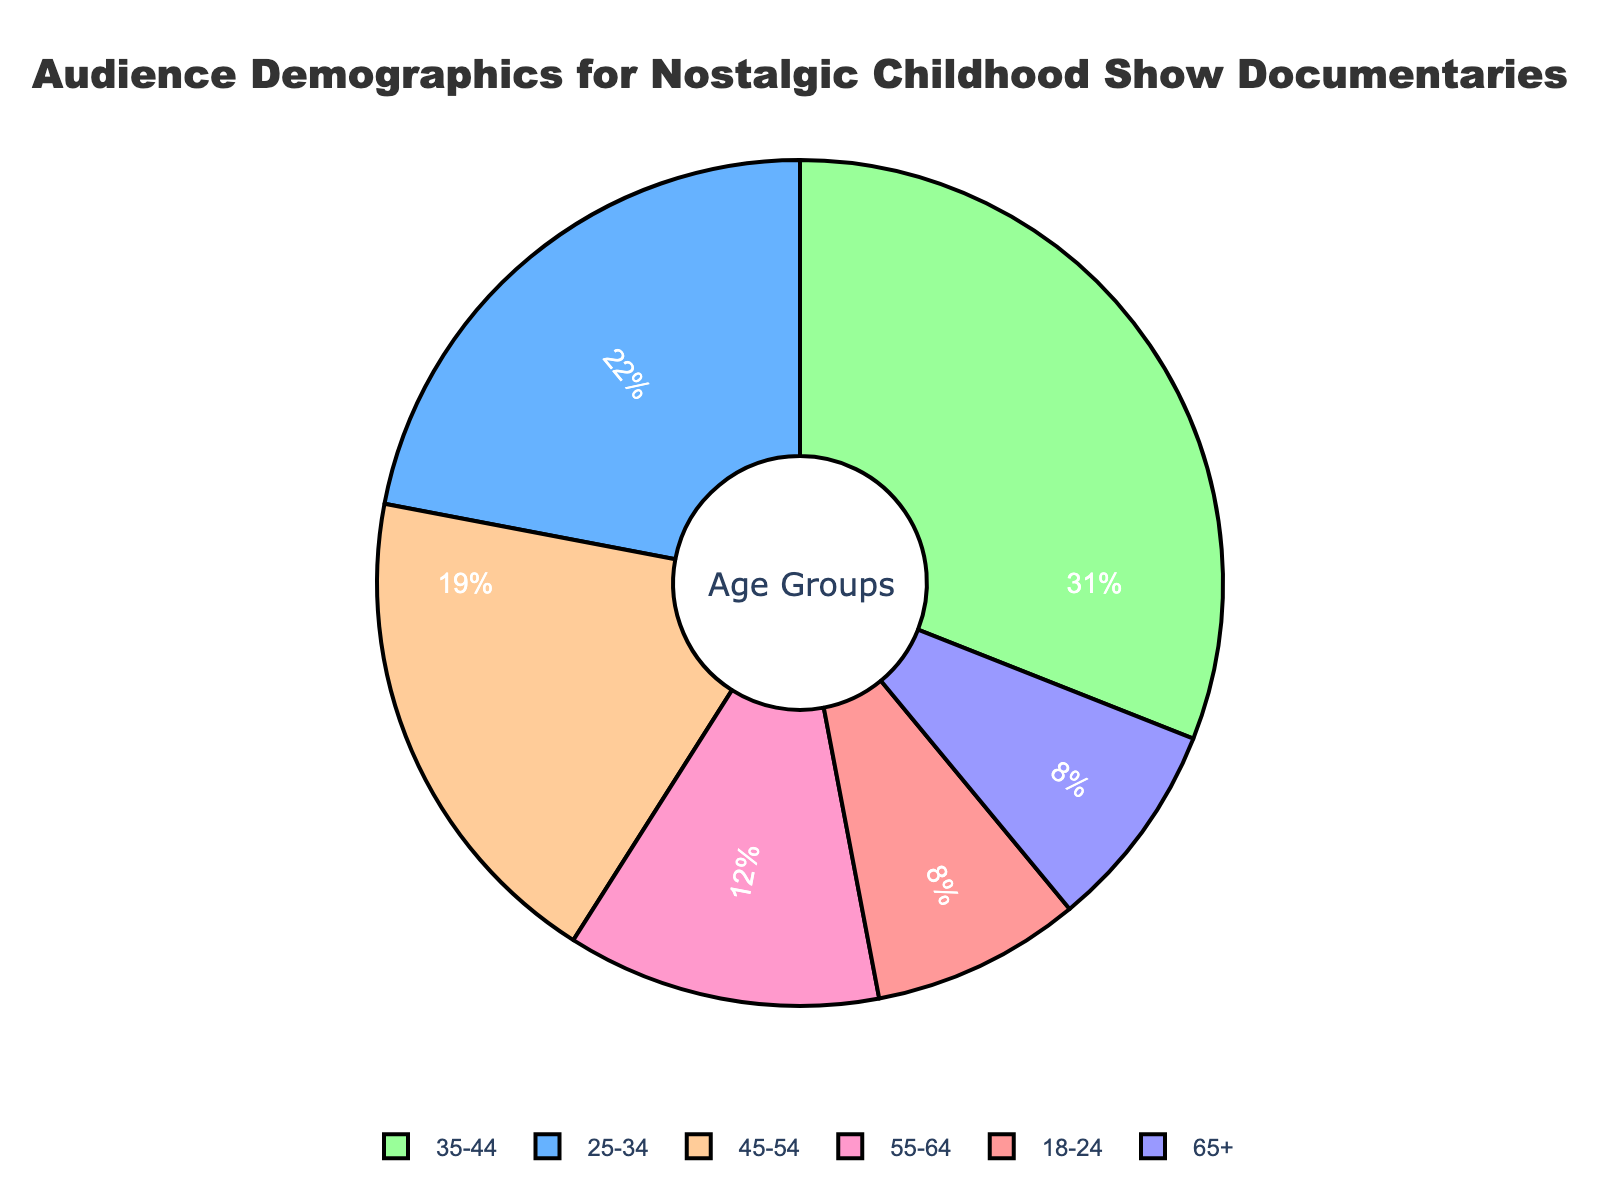What age group forms the largest portion of the audience? The pie chart shows different age groups and their respective percentages. The largest portion is associated with the age group that has the highest percentage. From the chart, the 35-44 age group has the largest portion with 31%.
Answer: 35-44 Which two age groups together make up over half of the audience? To determine which two age groups together make up over half (more than 50%), we look for the top two age groups by percentage and sum them. The two largest age groups are 35-44 (31%) and 25-34 (22%). Adding these together: 31% + 22% = 53%, which is over half.
Answer: 35-44 and 25-34 By how much does the percentage of the 35-44 age group exceed the percentage of the 55-64 age group? First, find the percentages of the 35-44 and the 55-64 age groups from the chart, which are 31% and 12%, respectively. Subtract the smaller percentage from the larger: 31% - 12% = 19%.
Answer: 19% Is the proportion of the 18-24 age group the same as the 65+ age group? From the pie chart, the 18-24 age group has an 8% share, and the 65+ age group also has an 8% share. Since these percentages are equal, the proportions are the same.
Answer: Yes Which age group has almost one-fifth of the audience? One-fifth of 100% is 20%. Check the percentages to see which one is closest to this value. The 45-54 age group has a percentage of 19%, which is almost one-fifth.
Answer: 45-54 Which age groups have the smallest and second smallest proportions of the audience? Locate the two smallest percentages in the pie chart. The smallest proportions are for the age groups 18-24 (8%) and 65+ (8%), both of which are equal and the smallest. Therefore, they both occupy the smallest and second smallest spots.
Answer: 18-24 and 65+ If we combine the 18-24 and 65+ age groups, what part of the total audience do they represent? Both the 18-24 and the 65+ age groups have a percentage of 8%. Adding these two proportions together gives 8% + 8% = 16%.
Answer: 16% What is the difference in audience percentage between the 25-34 and 45-54 age groups? From the pie chart, the 25-34 age group has 22%, and the 45-54 age group has 19%. Subtract the smaller percentage from the larger: 22% - 19% = 3%.
Answer: 3% Which age group is closest in size to the 55-64 age group? The 55-64 age group has a 12% share. Looking at the rest of the age groups, the 18-24 and 65+ each have an 8% share, but closest by comparison is the 45-54 age group at 19%, which is the nearest. Calculate absolute differences to verify:
Answer: 45-54 What percentage of the audience is above 45 years old? Add the percentages of the age groups above 45 years: 45-54 (19%), 55-64 (12%), and 65+ (8%). Sum these to find the total percentage: 19% + 12% + 8% = 39%.
Answer: 39% 